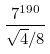Convert formula to latex. <formula><loc_0><loc_0><loc_500><loc_500>\frac { 7 ^ { 1 9 0 } } { \sqrt { 4 } / 8 }</formula> 